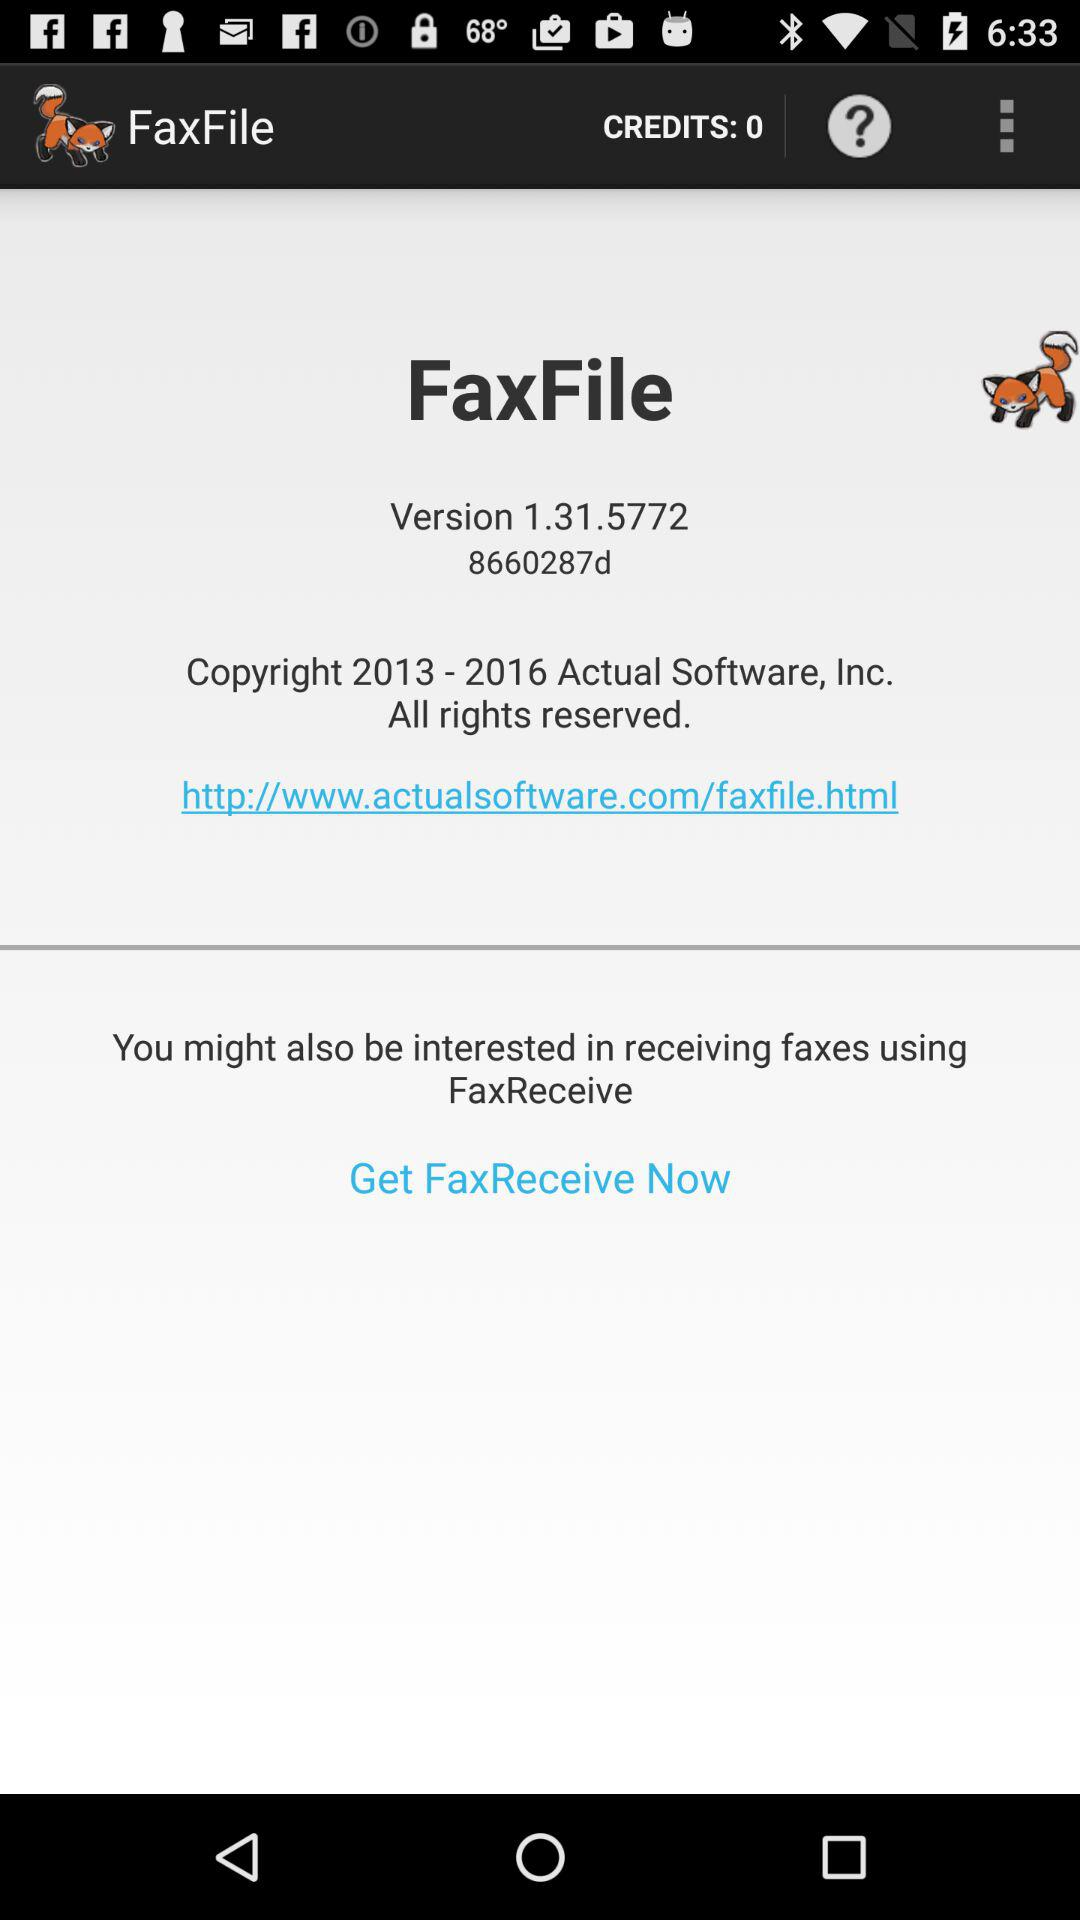How many credits are in "FaxFile"? There are 0 credits in "FaxFile". 